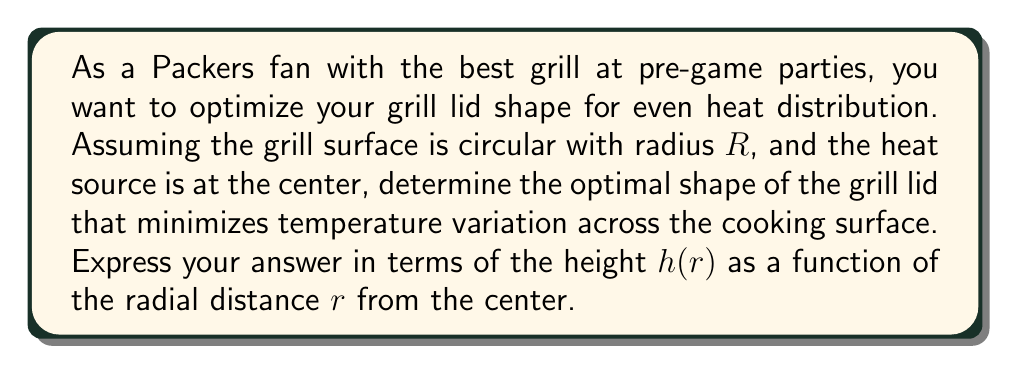Give your solution to this math problem. To solve this problem, we'll use principles from differential geometry and heat distribution:

1. The goal is to create a surface where the heat from the center source reaches all points on the circular grill surface simultaneously.

2. This is analogous to the brachistochrone problem, where we seek a curve that allows an object to travel between two points in the least time under gravity.

3. In our case, we want the heat to travel along geodesics (shortest paths) from the center to all points on the circular surface in equal time.

4. The solution to this problem is a surface of revolution generated by rotating a catenary curve around the vertical axis.

5. The catenary curve is given by the equation:

   $$y = a \cosh(\frac{x}{a})$$

   where $a$ is a constant that determines the scale of the curve.

6. In our case, we want $h(r)$ as a function of $r$. Rotating the catenary around the y-axis and solving for $h$, we get:

   $$h(r) = a \cosh(\frac{R}{a}) - a \cosh(\frac{r}{a})$$

7. The constant $a$ can be determined by the desired height of the lid at the edge of the grill ($r = R$). Let's call this height $H$. Then:

   $$H = a \cosh(\frac{R}{a}) - a$$

8. This equation can be solved numerically for $a$ given $R$ and $H$.

Therefore, the optimal shape of the grill lid for even heat distribution is described by the equation in step 6, with $a$ determined by the equation in step 7.
Answer: $$h(r) = a \cosh(\frac{R}{a}) - a \cosh(\frac{r}{a})$$
where $a$ satisfies $H = a \cosh(\frac{R}{a}) - a$ 